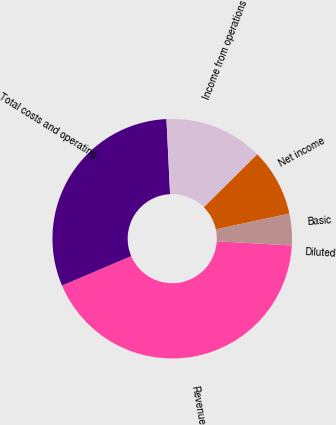Convert chart to OTSL. <chart><loc_0><loc_0><loc_500><loc_500><pie_chart><fcel>Revenue<fcel>Total costs and operating<fcel>Income from operations<fcel>Net income<fcel>Basic<fcel>Diluted<nl><fcel>42.69%<fcel>30.63%<fcel>13.34%<fcel>9.07%<fcel>4.27%<fcel>0.0%<nl></chart> 